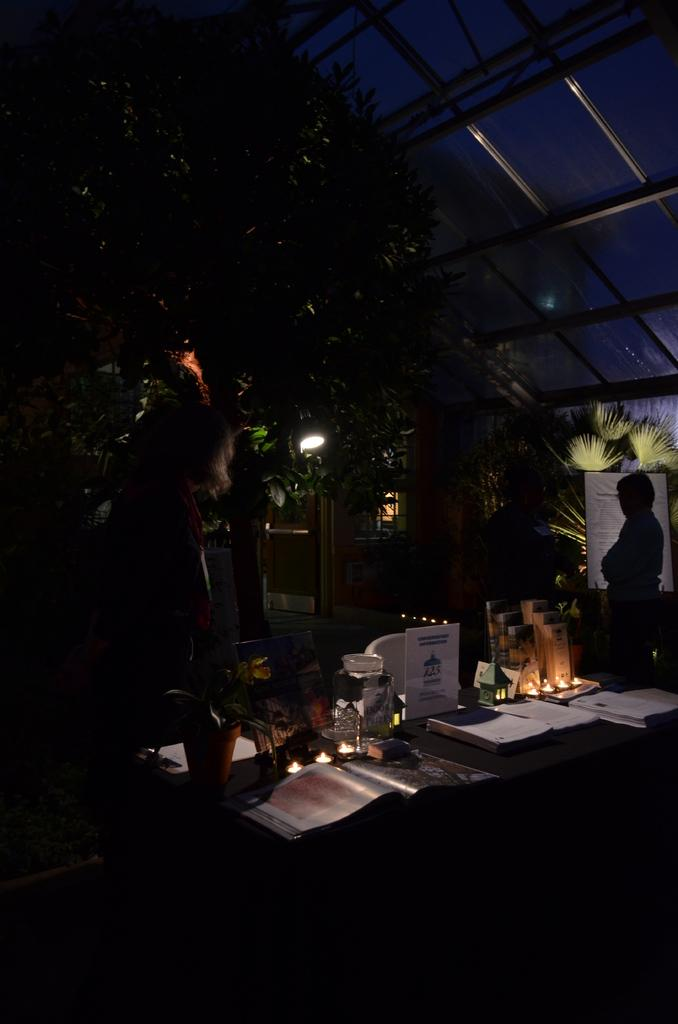What type of objects can be seen in the image? There are books and jars in the image. Where are these objects located? The objects are placed on a table in the image. What can be seen in the background of the image? There are trees and people visible in the background of the image. What type of fuel is being used by the people in the image? There is no indication of any fuel being used in the image; it only shows books, jars, a table, trees, and people. 